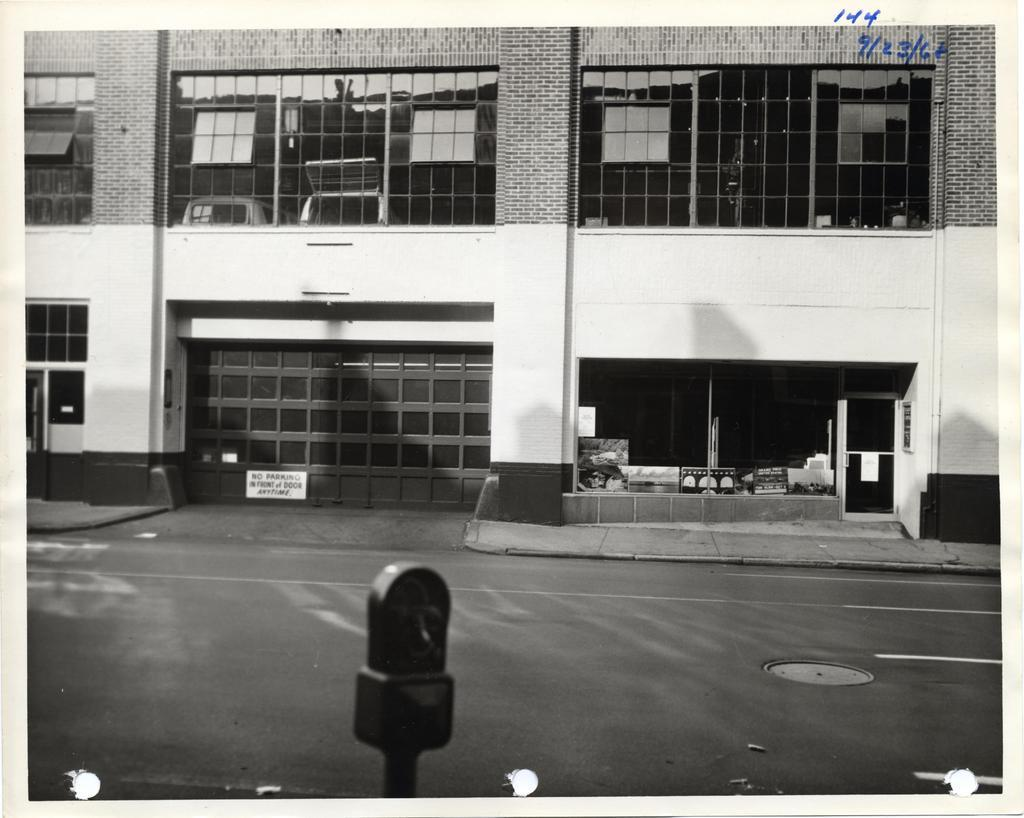What is the main feature of the image? There is a road in the image. What can be seen near the road? There is a building beside the road. What is a notable characteristic of the building? The building has windows. What type of fork can be seen in the image? There is no fork present in the image. What meal is being prepared in the building? There is no indication of a meal being prepared in the building; the image only shows a road and a building with windows. 